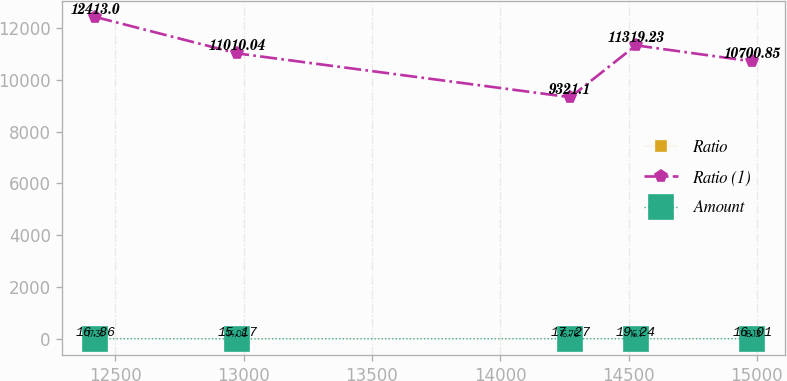<chart> <loc_0><loc_0><loc_500><loc_500><line_chart><ecel><fcel>Ratio<fcel>Ratio (1)<fcel>Amount<nl><fcel>12422<fcel>16.86<fcel>12413<fcel>17.31<nl><fcel>12974.8<fcel>15.17<fcel>11010<fcel>14.06<nl><fcel>14272.8<fcel>17.27<fcel>9321.1<fcel>16.76<nl><fcel>14528.9<fcel>19.24<fcel>11319.2<fcel>16.1<nl><fcel>14982.9<fcel>16.01<fcel>10700.9<fcel>18.13<nl></chart> 